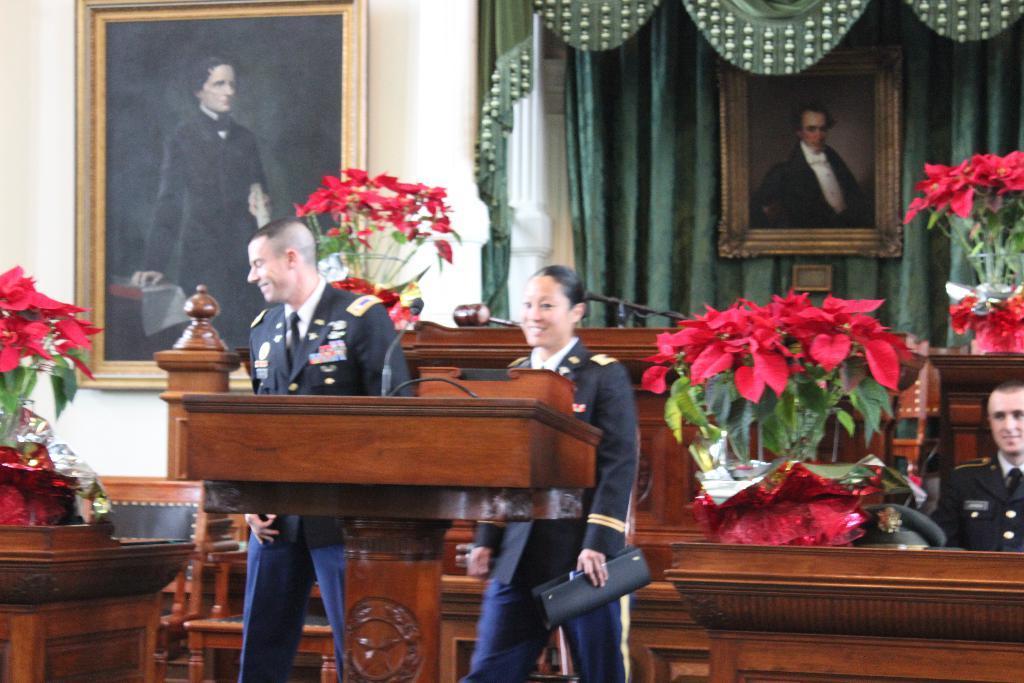How would you summarize this image in a sentence or two? In this image we can see a three people, two of them are standing, one lady is holding a file, there are some bouquets, photo frames, there is a podium, a hammer, cap on the table, there is a curtain, also we can see the wall. 